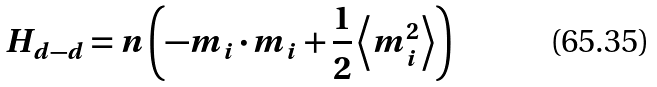<formula> <loc_0><loc_0><loc_500><loc_500>H _ { d - d } = n \left ( - m _ { i } \cdot m _ { i } + \frac { 1 } { 2 } \left \langle m _ { i } ^ { 2 } \right \rangle \right )</formula> 